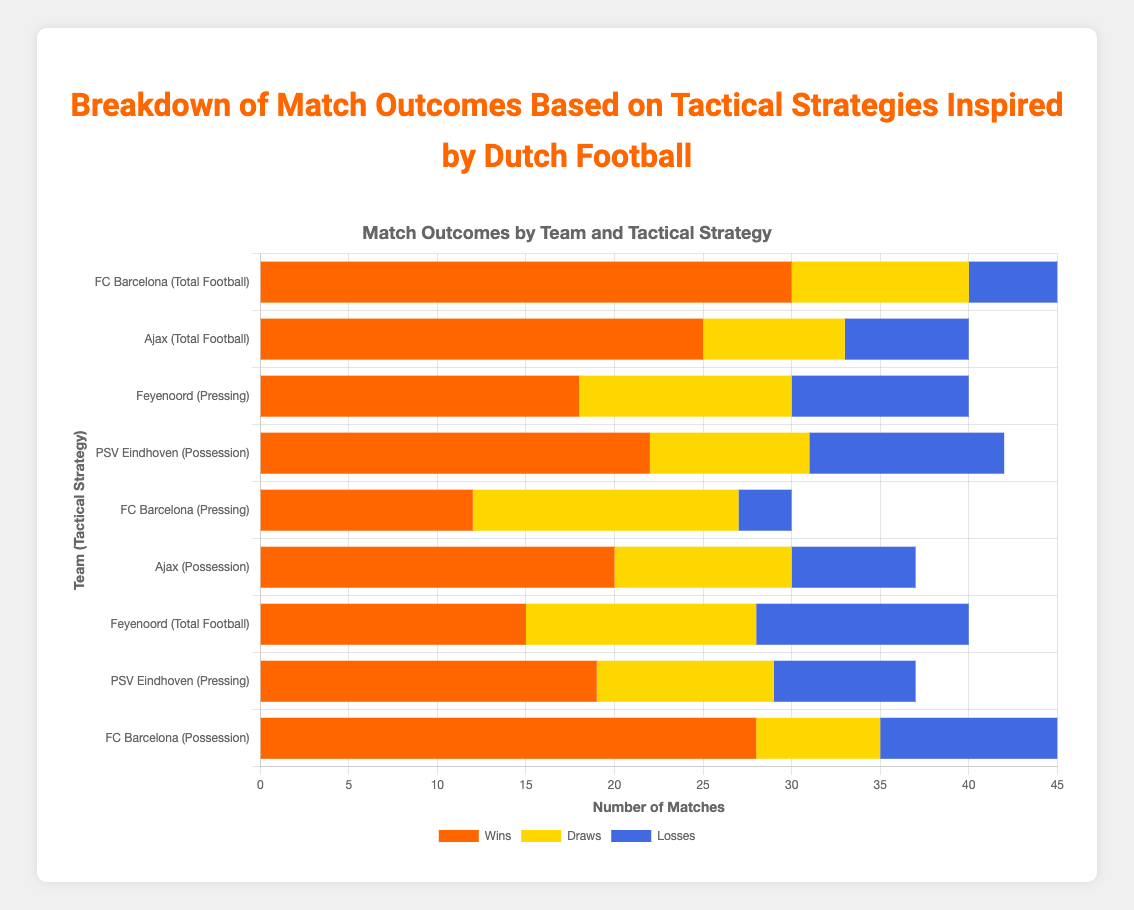Which team has the highest number of wins using "Total Football"? Look at the bars labeled with "Total Football" and compare the heights of the orange (Wins) sections. FC Barcelona's orange bar for "Total Football" is the longest with 30 wins.
Answer: FC Barcelona How many draws combined did FC Barcelona achieve with all tactical strategies? Combine the draws from FC Barcelona using different tactics: Total Football (10) + Pressing (15) + Possession (7). Adding these together: 10 + 15 + 7 = 32.
Answer: 32 Which tactical strategy has the most balanced outcome (wins, draws, losses) for Feyenoord? The most balanced distribution will have bars of similar lengths. Feyenoord's "Pressing" strategy has wins (18), draws (12), and losses (10), which are more balanced compared to the other tactics.
Answer: Pressing How many total matches did Ajax play using "Possession"? Add the wins, draws, and losses for Ajax under the "Possession" strategy: Wins (20) + Draws (10) + Losses (7). Hence, 20 + 10 + 7 = 37.
Answer: 37 Which team and strategy combination has the lowest number of losses? Look for the smallest blue (Losses) bar among all team-strategy combinations. FC Barcelona's "Pressing" strategy has the shortest losses bar with only 3 losses.
Answer: FC Barcelona (Pressing) Which tactical strategy shows the highest wins for PSV Eindhoven? Compare the lengths of the orange (Wins) sections for PSV Eindhoven. Their "Possession" strategy has 22 wins, which is the longest among their tactics.
Answer: Possession How many more wins did FC Barcelona have with "Total Football" compared to "Pressing"? Subtract the wins with "Pressing" (12) from the wins with "Total Football" (30). Hence, 30 - 12 = 18.
Answer: 18 Which team's "Total Football" strategy had the highest number of losses? Compare the lengths of the blue (Losses) sections for "Total Football". Feyenoord's "Total Football" blue bar is longest with 12 losses.
Answer: Feyenoord Which team had more draws using "Pressing" strategy, Feyenoord or PSV Eindhoven? Compare the yellow (Draws) bars for Feyenoord and PSV Eindhoven under "Pressing". Feyenoord has 12 draws, and PSV Eindhoven has 10. So, Feyenoord has more draws.
Answer: Feyenoord 